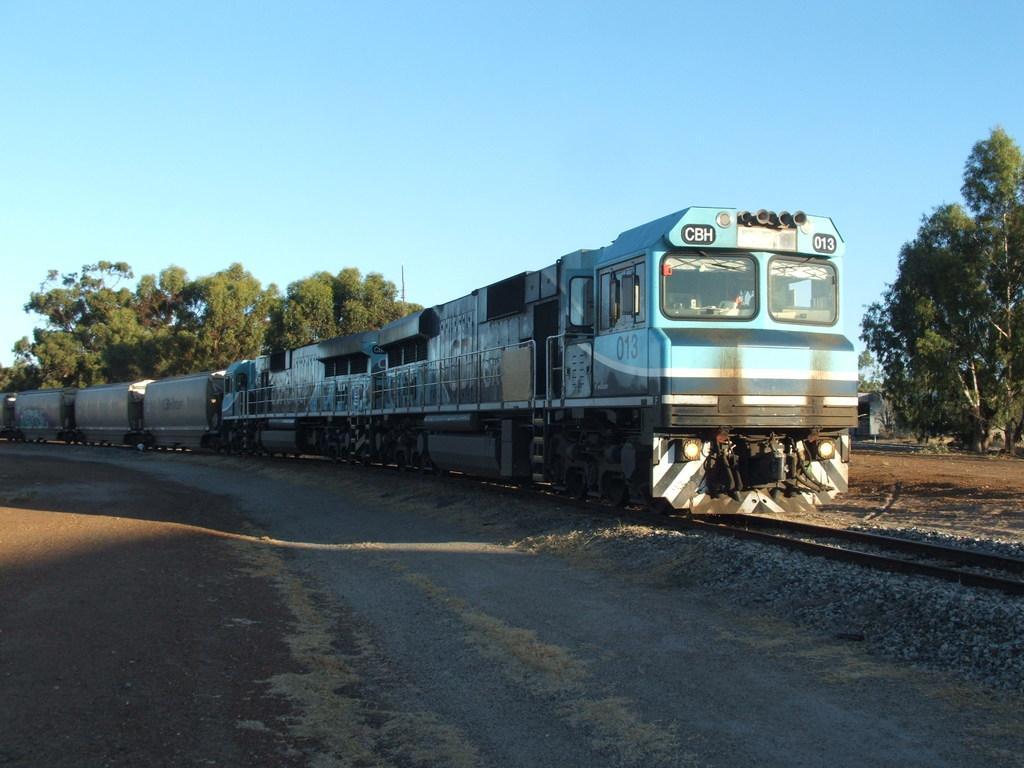In one or two sentences, can you explain what this image depicts? In the center of the image there is a train on the railway track. On the left side of the image there is a road. In the background of the image there are trees and sky. 